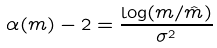<formula> <loc_0><loc_0><loc_500><loc_500>\alpha ( m ) - 2 = \frac { \log ( m / \hat { m } ) } { \sigma ^ { 2 } }</formula> 